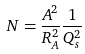<formula> <loc_0><loc_0><loc_500><loc_500>N = \frac { A ^ { 2 } } { R _ { A } ^ { 2 } } \frac { 1 } { Q _ { s } ^ { 2 } }</formula> 